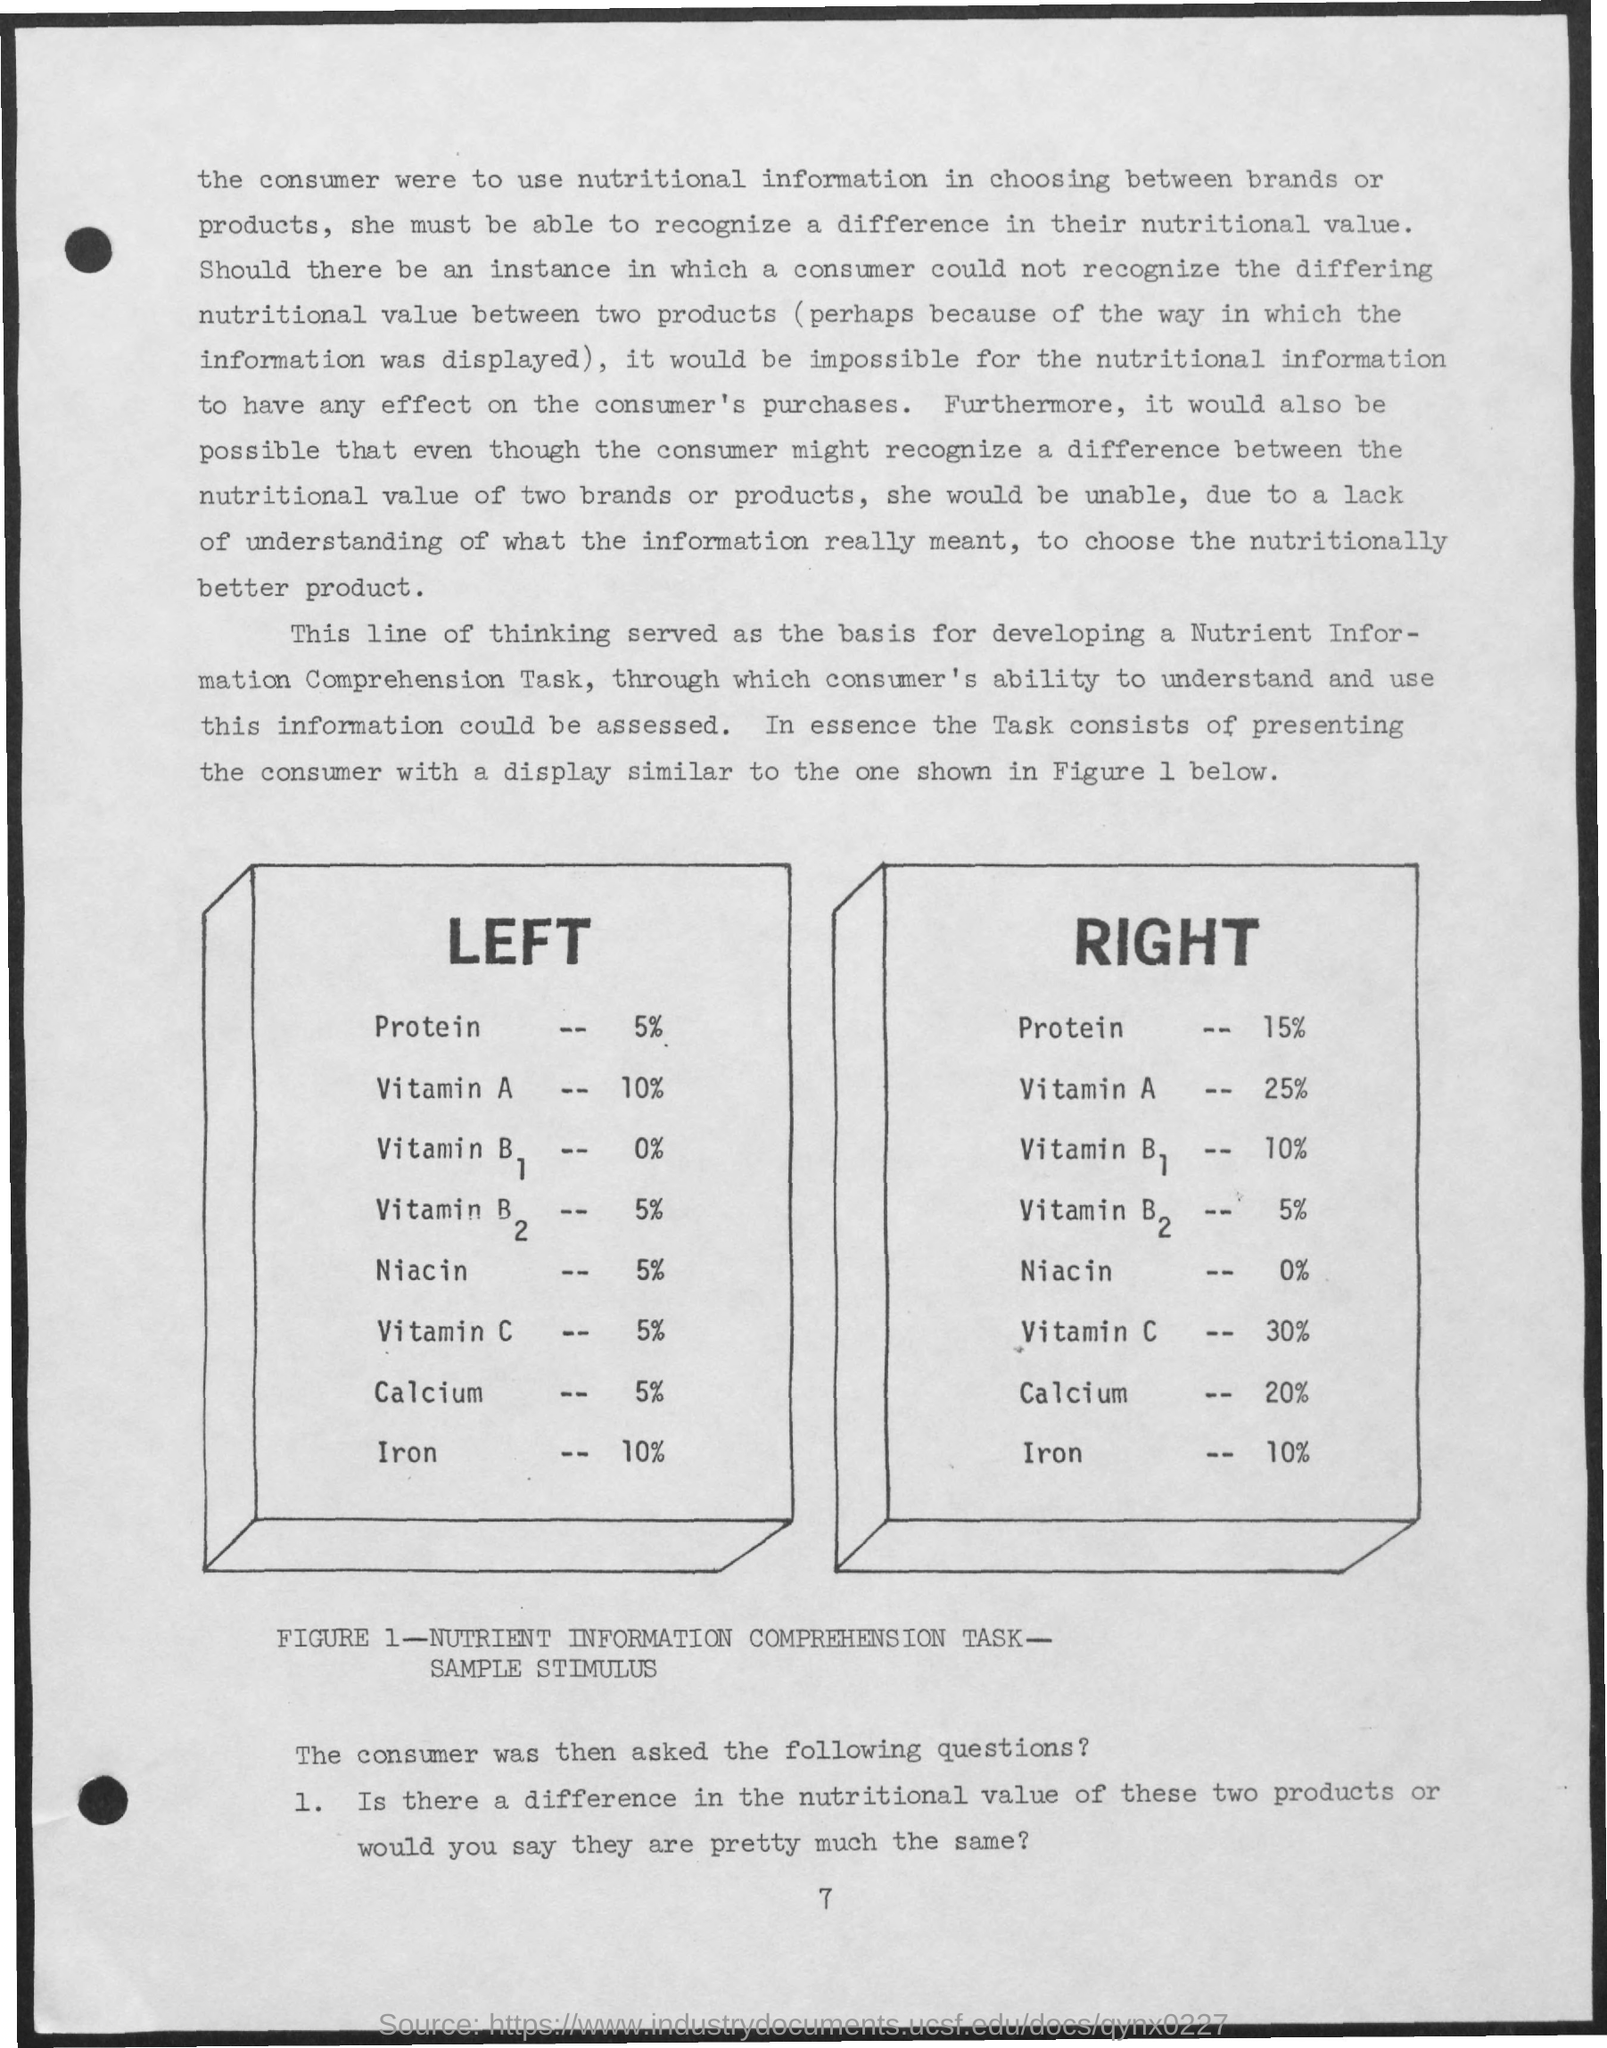Specify some key components in this picture. The amount of calcium on the right is equal to 20%. The right side of the paper contains 0% of niacin. The page number is 7. The percentage of protein on the left is 5%. The percentage of iron on the right is 10%. 